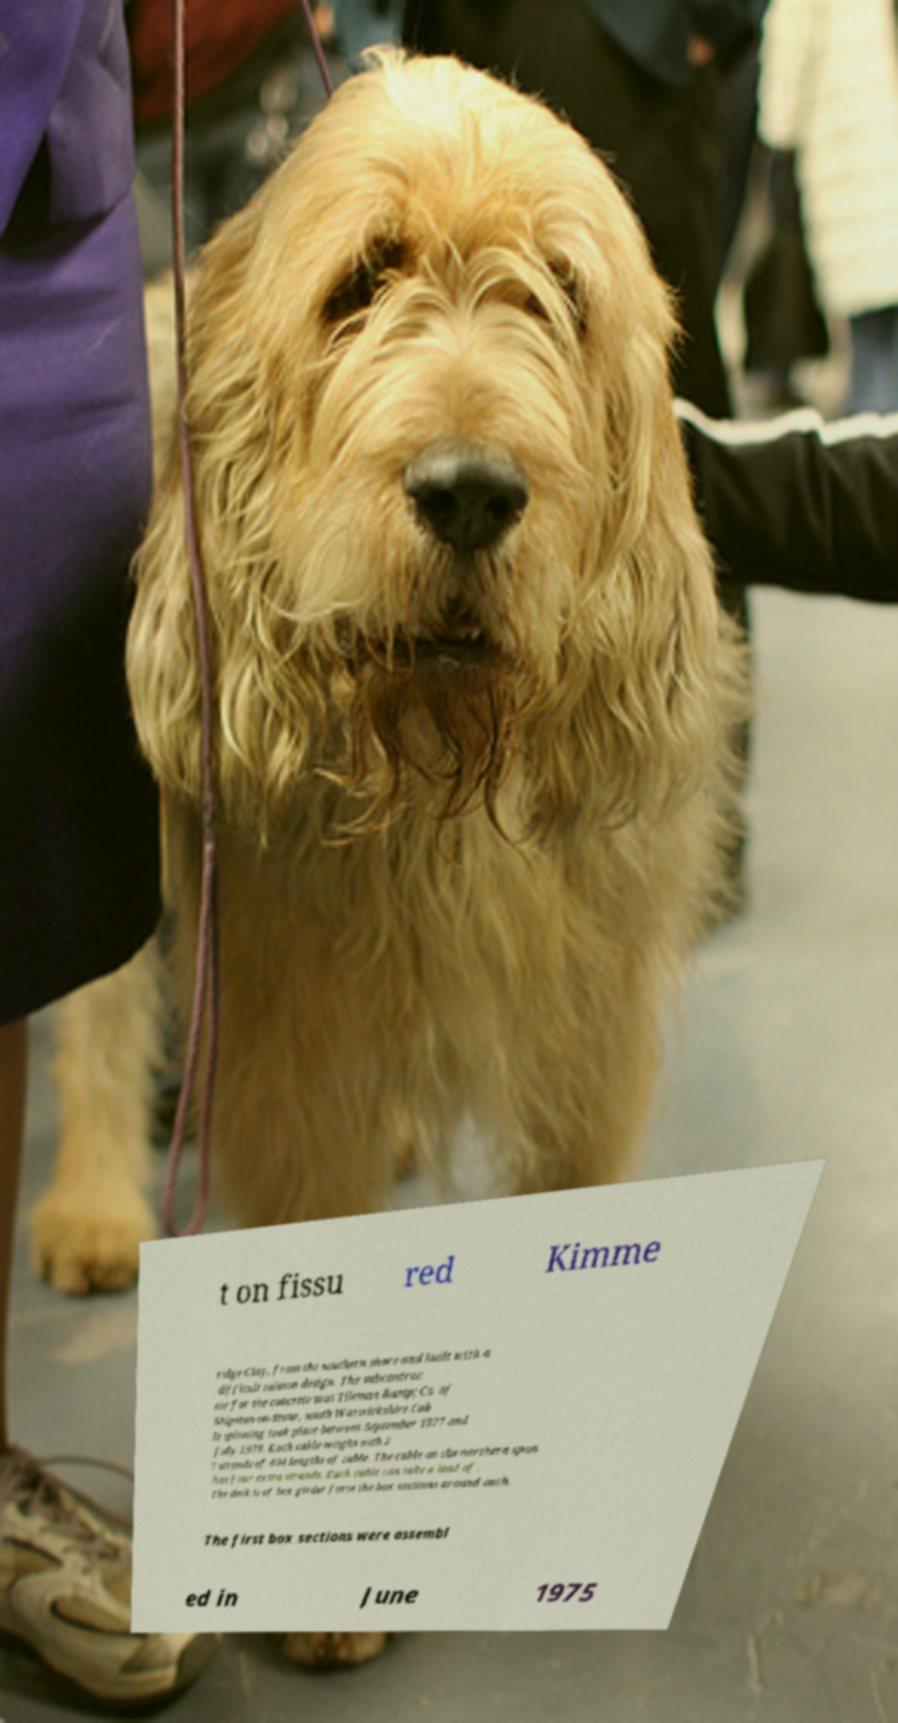There's text embedded in this image that I need extracted. Can you transcribe it verbatim? t on fissu red Kimme ridge Clay, from the southern shore and built with a difficult caisson design. The subcontrac tor for the concrete was Tileman &amp; Co. of Shipston-on-Stour, south Warwickshire.Cab le spinning took place between September 1977 and July 1979. Each cable weighs with 3 7 strands of 404 lengths of cable. The cable on the northern span has four extra strands. Each cable can take a load of . The deck is of box girder form the box sections around each. The first box sections were assembl ed in June 1975 